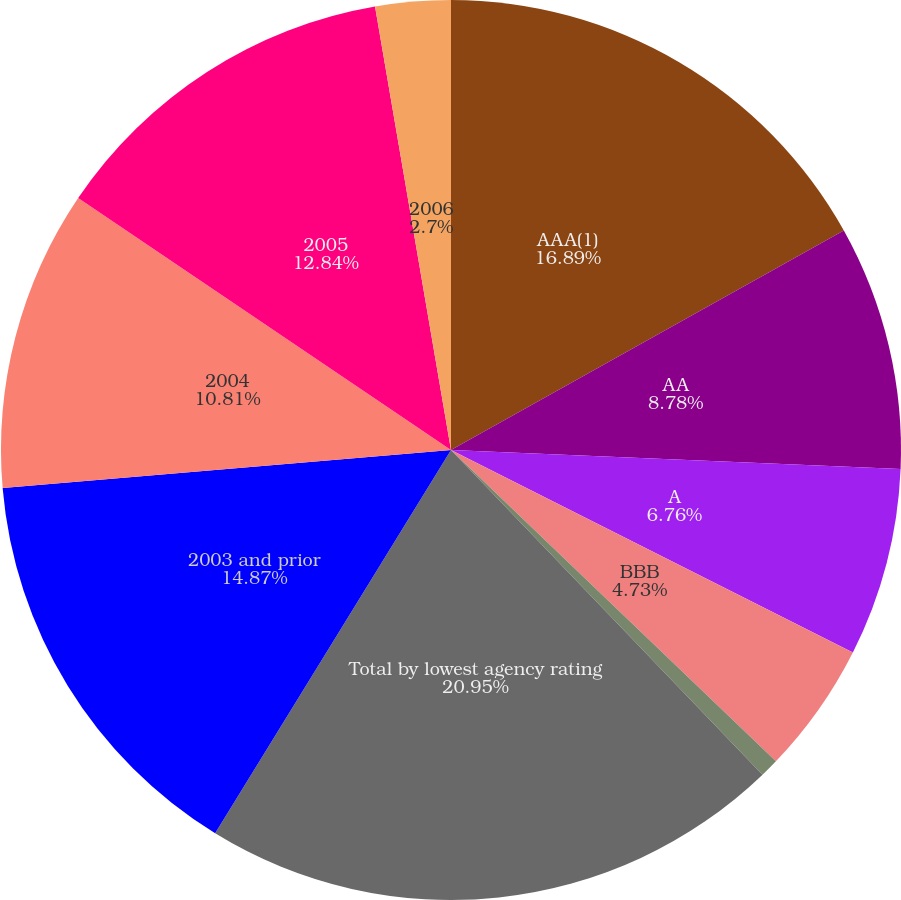<chart> <loc_0><loc_0><loc_500><loc_500><pie_chart><fcel>AAA(1)<fcel>AA<fcel>A<fcel>BBB<fcel>BB and below<fcel>Total by lowest agency rating<fcel>2003 and prior<fcel>2004<fcel>2005<fcel>2006<nl><fcel>16.89%<fcel>8.78%<fcel>6.76%<fcel>4.73%<fcel>0.67%<fcel>20.95%<fcel>14.87%<fcel>10.81%<fcel>12.84%<fcel>2.7%<nl></chart> 